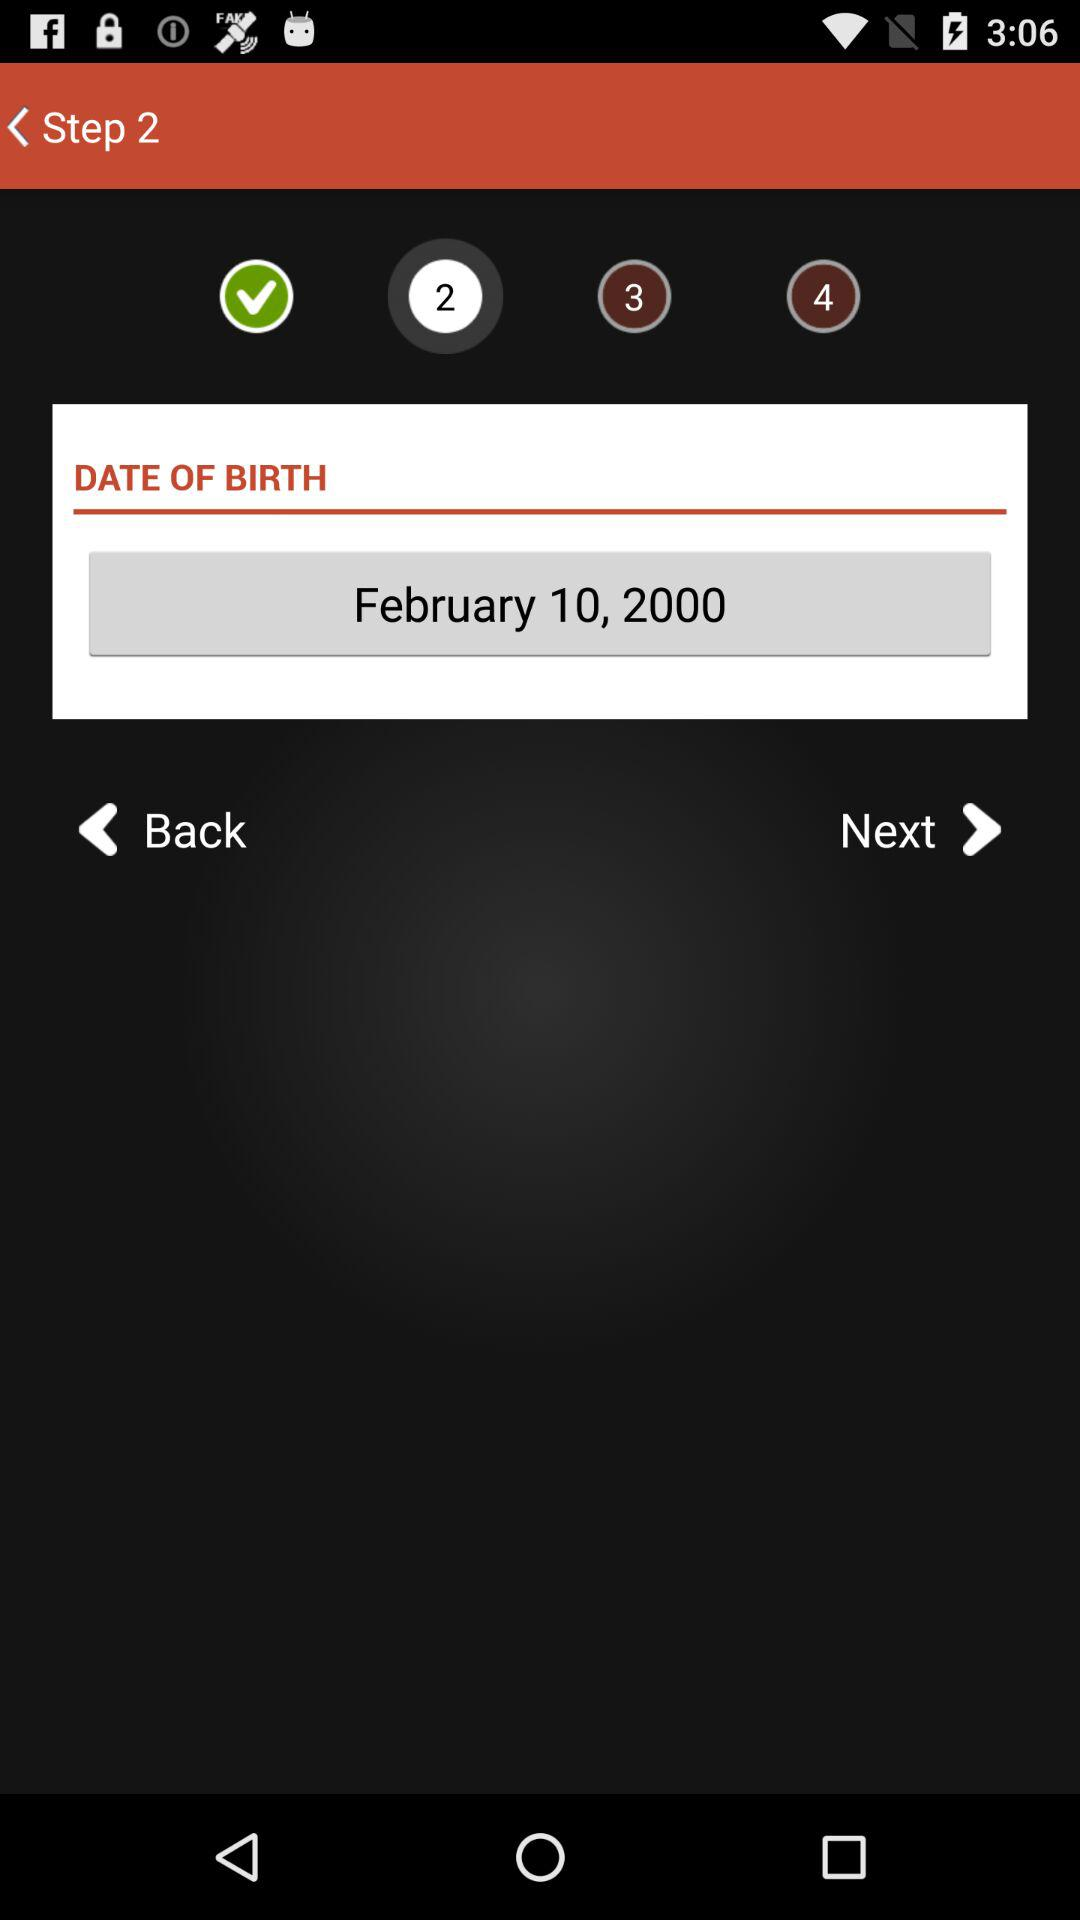How many total steps are there? There are 4 steps. 